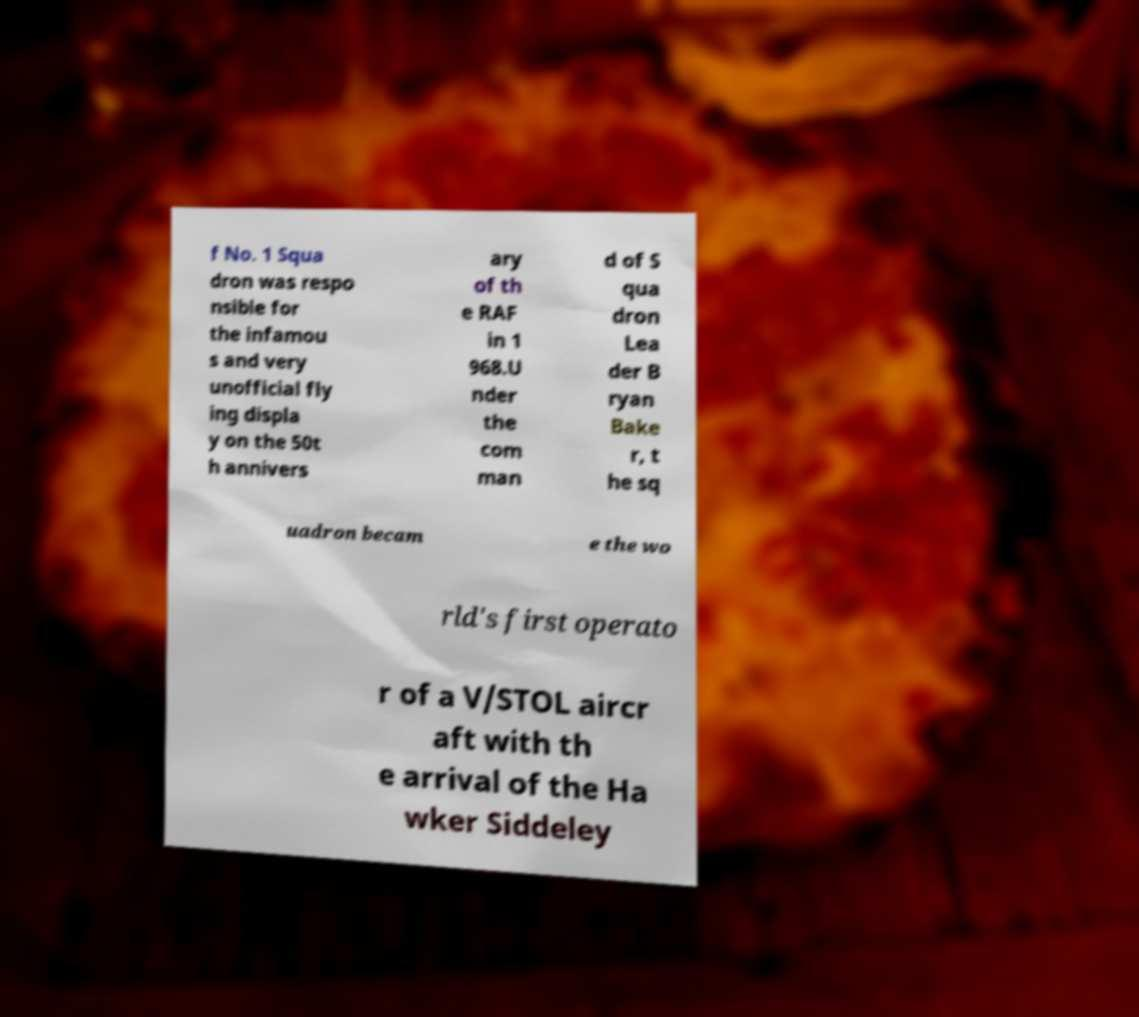Can you read and provide the text displayed in the image?This photo seems to have some interesting text. Can you extract and type it out for me? f No. 1 Squa dron was respo nsible for the infamou s and very unofficial fly ing displa y on the 50t h annivers ary of th e RAF in 1 968.U nder the com man d of S qua dron Lea der B ryan Bake r, t he sq uadron becam e the wo rld's first operato r of a V/STOL aircr aft with th e arrival of the Ha wker Siddeley 